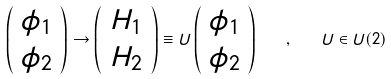<formula> <loc_0><loc_0><loc_500><loc_500>\left ( \begin{array} { c } \phi _ { 1 } \\ \phi _ { 2 } \end{array} \right ) \rightarrow \left ( \begin{array} { c } H _ { 1 } \\ H _ { 2 } \end{array} \right ) \equiv U \left ( \begin{array} { c } \phi _ { 1 } \\ \phi _ { 2 } \end{array} \right ) \quad , \quad U \in U ( 2 )</formula> 